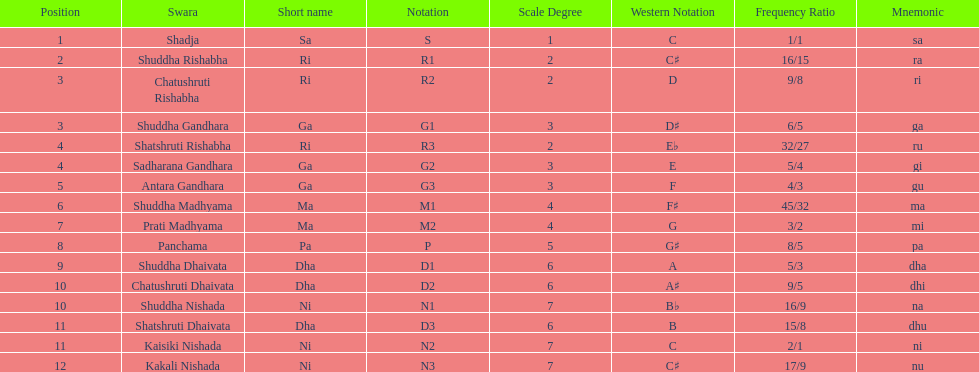List each pair of swaras that share the same position. Chatushruti Rishabha, Shuddha Gandhara, Shatshruti Rishabha, Sadharana Gandhara, Chatushruti Dhaivata, Shuddha Nishada, Shatshruti Dhaivata, Kaisiki Nishada. 